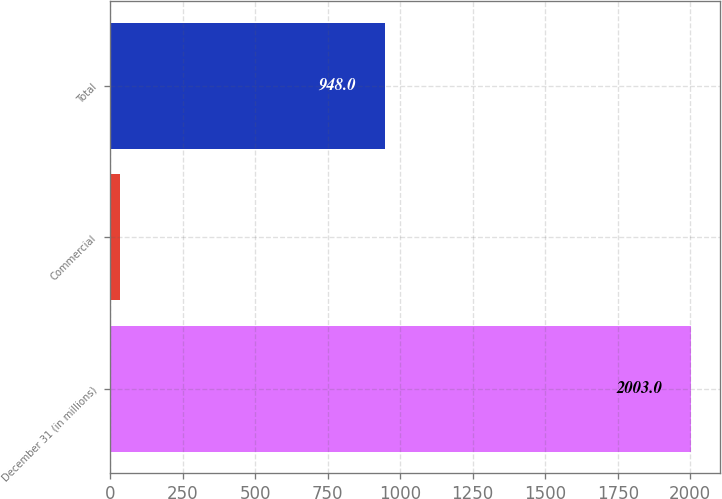Convert chart to OTSL. <chart><loc_0><loc_0><loc_500><loc_500><bar_chart><fcel>December 31 (in millions)<fcel>Commercial<fcel>Total<nl><fcel>2003<fcel>34<fcel>948<nl></chart> 